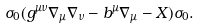<formula> <loc_0><loc_0><loc_500><loc_500>\sigma _ { 0 } ( g ^ { \mu \nu } \nabla _ { \mu } \nabla _ { \nu } - b ^ { \mu } \nabla _ { \mu } - X ) \sigma _ { 0 } .</formula> 